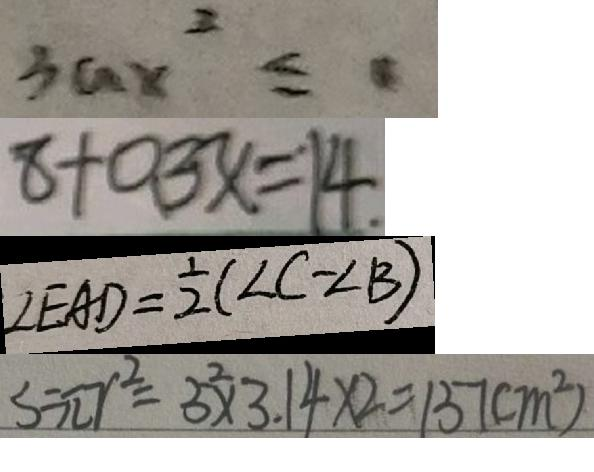<formula> <loc_0><loc_0><loc_500><loc_500>3 a x ^ { 2 } \leq 0 
 8 + 0 . 3 x = 1 4 . 
 \angle E A D = \frac { 1 } { 2 } ( \angle C - \angle B ) 
 S = \pi r ^ { 2 } = 5 ^ { 2 } \times 3 . 1 4 \times 2 = 1 5 7 ( m ^ { 2 } )</formula> 